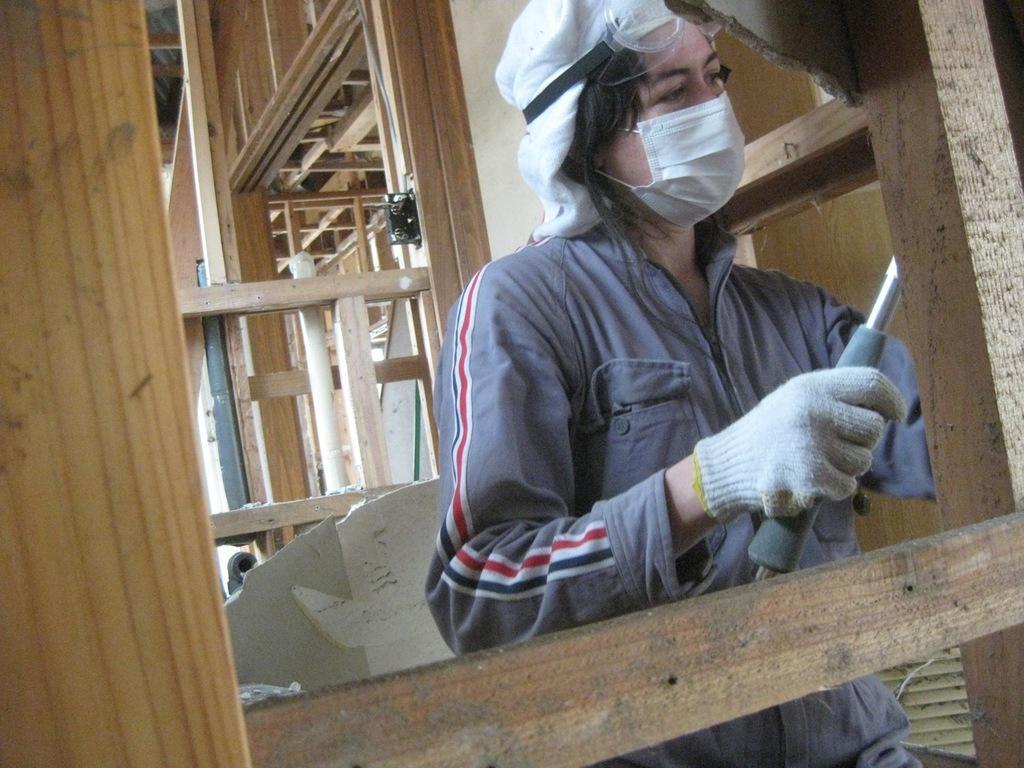Describe this image in one or two sentences. In this image we can see a person standing holding a metal rod. We can also see the wooden frames, a fan and a wall. 